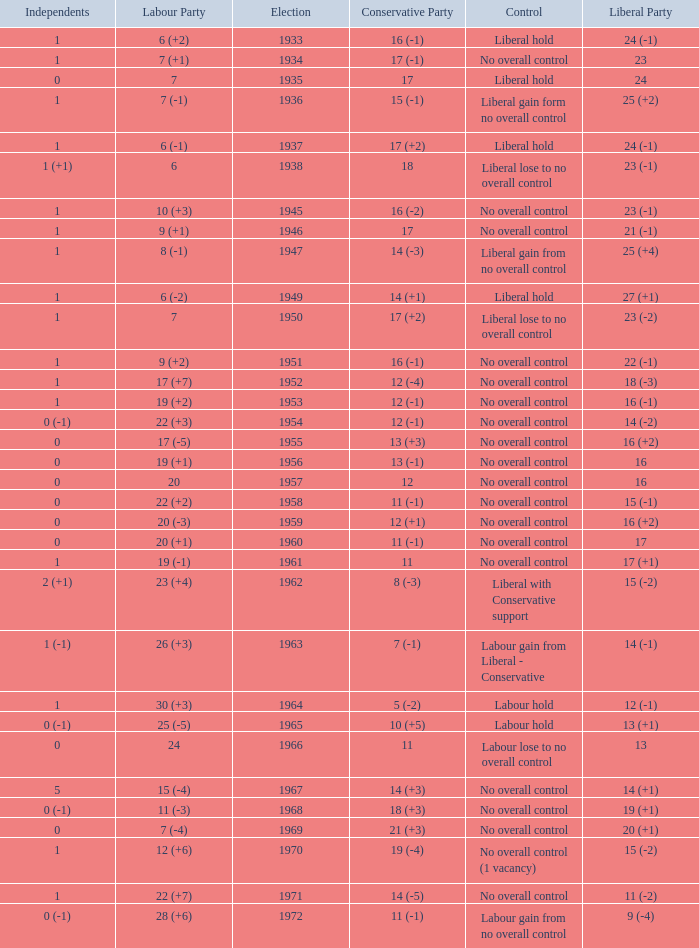What was the Liberal Party result from the election having a Conservative Party result of 16 (-1) and Labour of 6 (+2)? 24 (-1). 